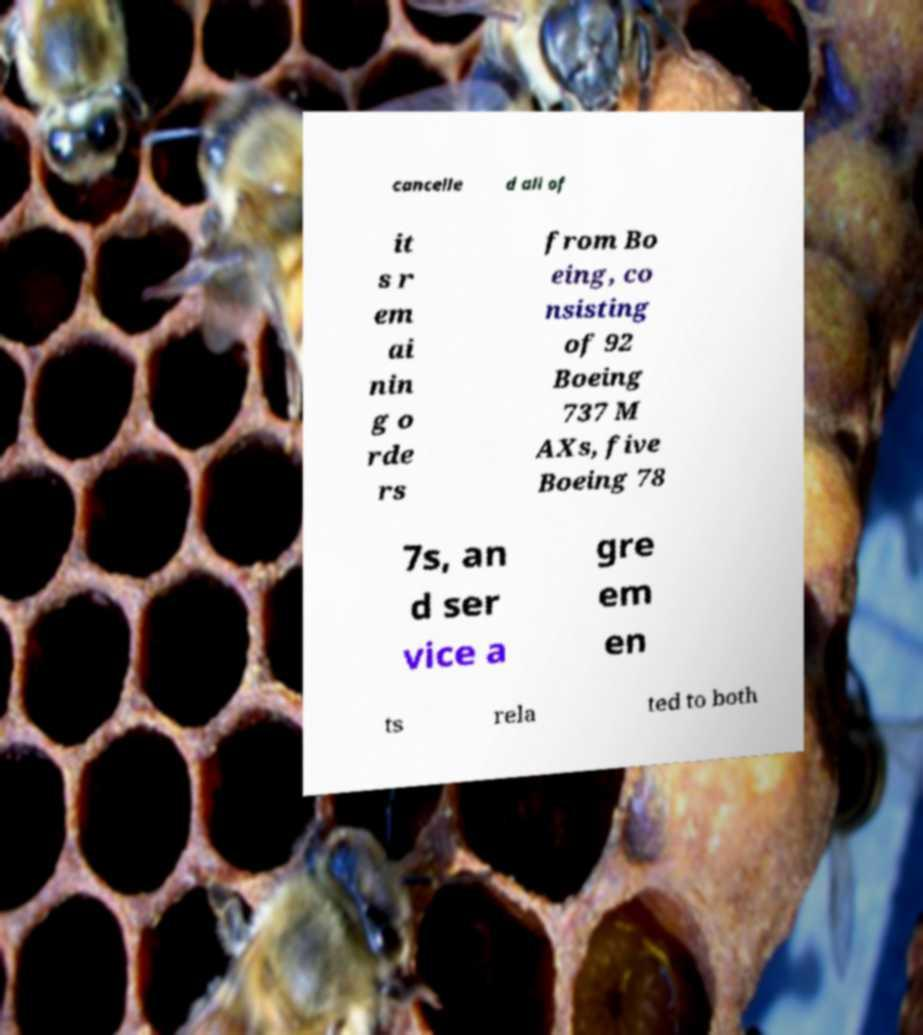What messages or text are displayed in this image? I need them in a readable, typed format. cancelle d all of it s r em ai nin g o rde rs from Bo eing, co nsisting of 92 Boeing 737 M AXs, five Boeing 78 7s, an d ser vice a gre em en ts rela ted to both 